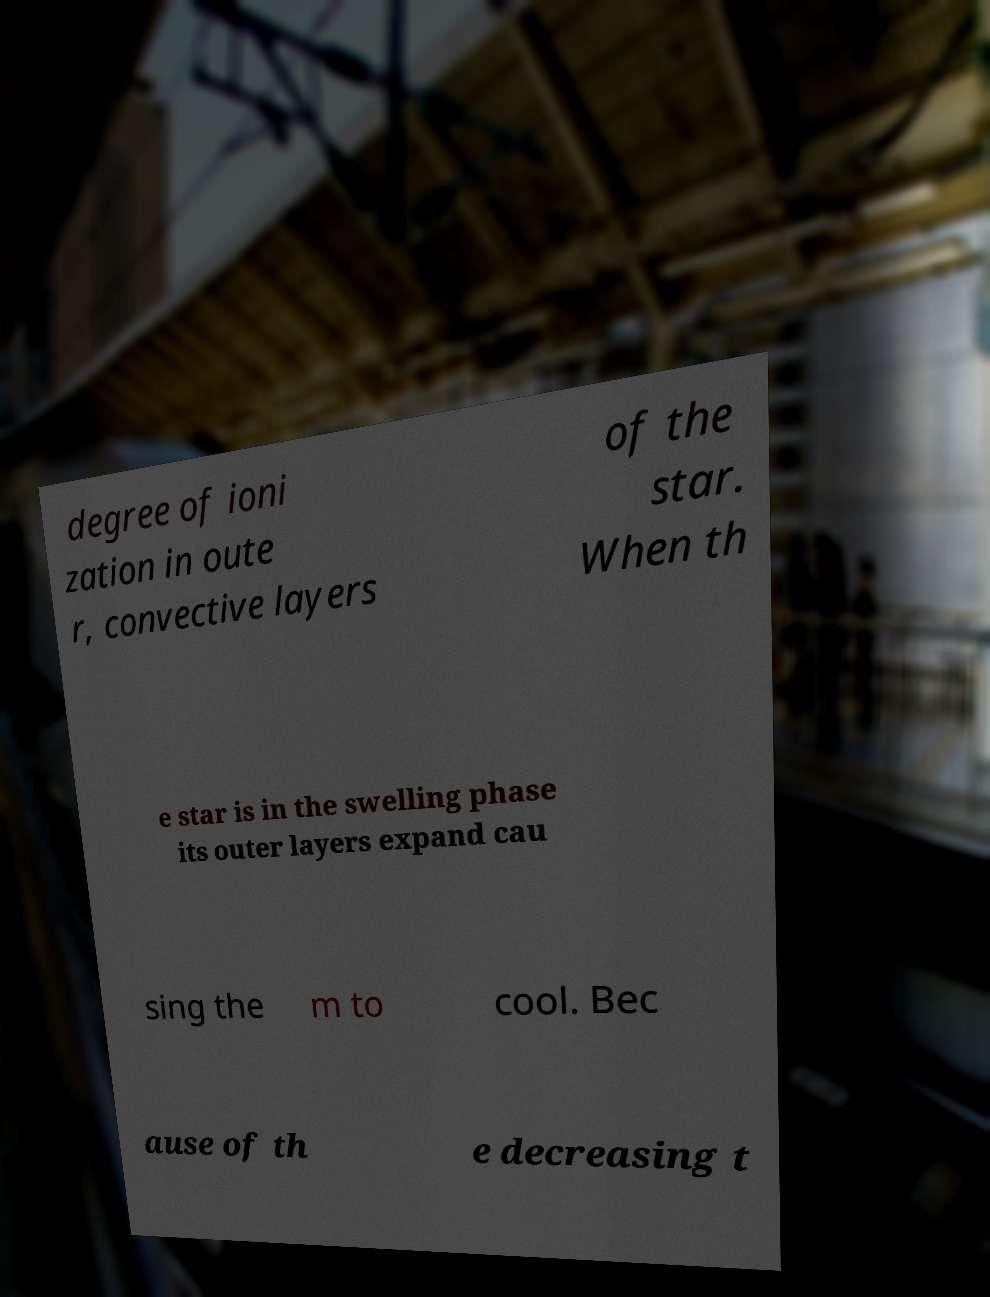Can you accurately transcribe the text from the provided image for me? degree of ioni zation in oute r, convective layers of the star. When th e star is in the swelling phase its outer layers expand cau sing the m to cool. Bec ause of th e decreasing t 